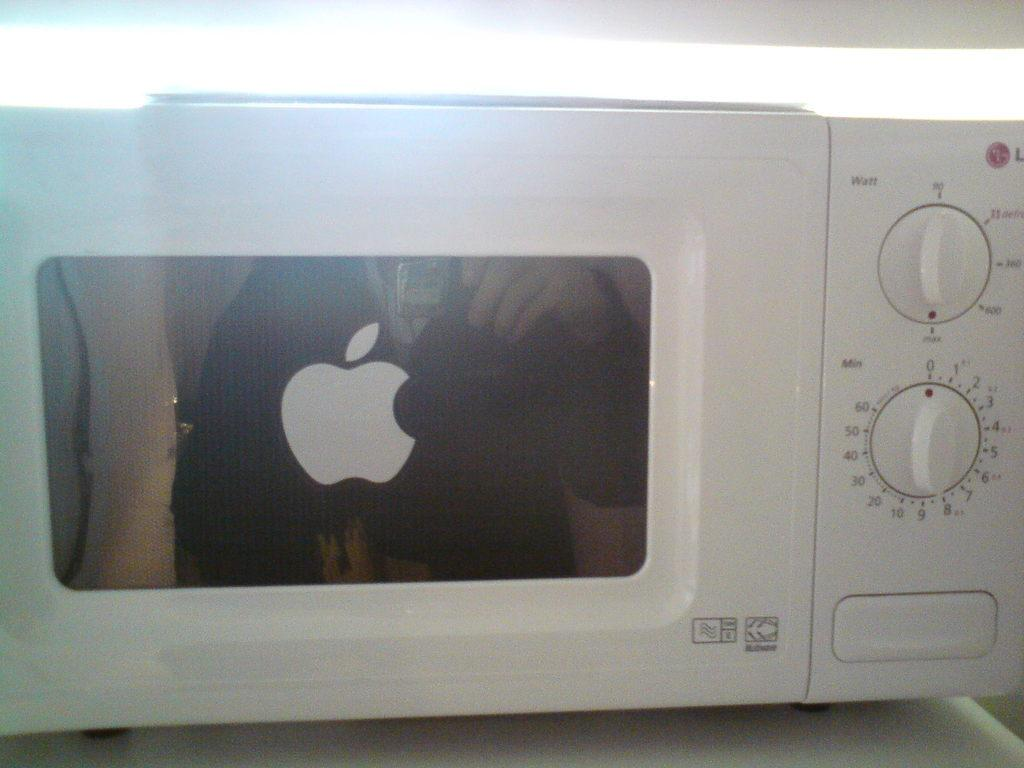<image>
Write a terse but informative summary of the picture. a white microwave with the top button for power level adjustment 